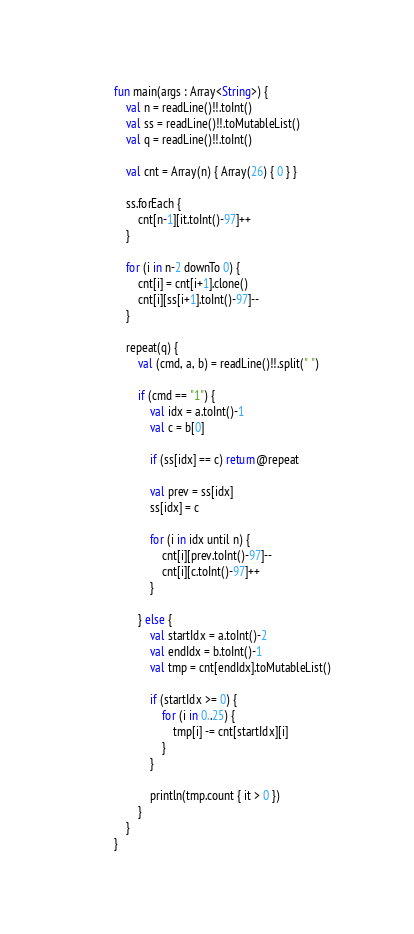Convert code to text. <code><loc_0><loc_0><loc_500><loc_500><_Kotlin_>fun main(args : Array<String>) {
    val n = readLine()!!.toInt()
    val ss = readLine()!!.toMutableList()
    val q = readLine()!!.toInt()

    val cnt = Array(n) { Array(26) { 0 } }

    ss.forEach {
        cnt[n-1][it.toInt()-97]++
    }

    for (i in n-2 downTo 0) {
        cnt[i] = cnt[i+1].clone()
        cnt[i][ss[i+1].toInt()-97]--
    }

    repeat(q) {
        val (cmd, a, b) = readLine()!!.split(" ")

        if (cmd == "1") {
            val idx = a.toInt()-1
            val c = b[0]

            if (ss[idx] == c) return@repeat

            val prev = ss[idx]
            ss[idx] = c

            for (i in idx until n) {
                cnt[i][prev.toInt()-97]--
                cnt[i][c.toInt()-97]++
            }

        } else {
            val startIdx = a.toInt()-2
            val endIdx = b.toInt()-1
            val tmp = cnt[endIdx].toMutableList()

            if (startIdx >= 0) {
                for (i in 0..25) {
                    tmp[i] -= cnt[startIdx][i]
                }
            }

            println(tmp.count { it > 0 })
        }
    }
}</code> 